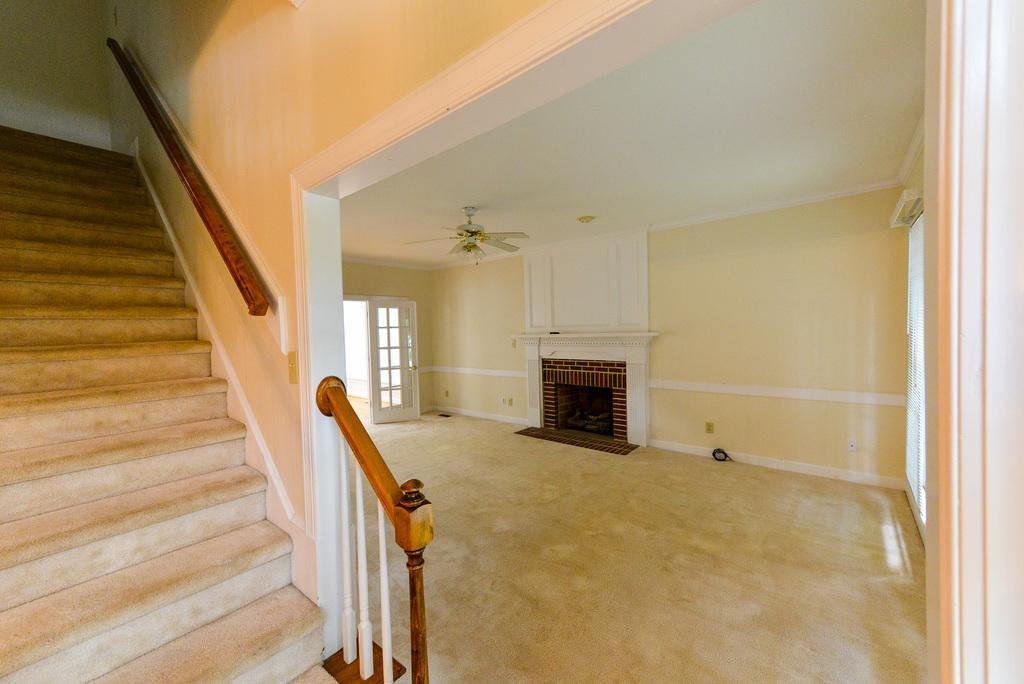How would you summarize this image in a sentence or two? This picture is clicked inside the room. On the left side, we see the staircase and the stair railing. Beside that, we see a white wall. On the right side, we see a wall and the windows. In the background, we see a wall and the fireplace. Beside that, we see a white door. At the top, we see the ceiling fan and the roof of the building. 